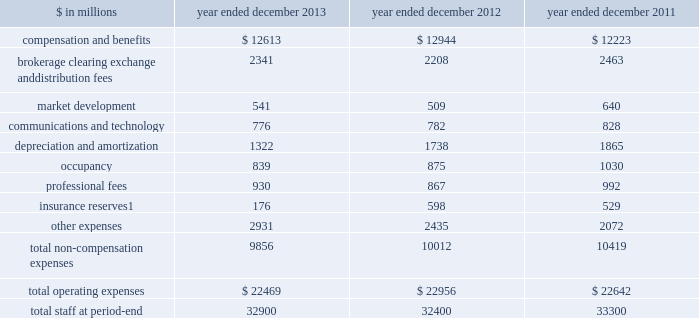Management 2019s discussion and analysis net interest income 2013 versus 2012 .
Net interest income on the consolidated statements of earnings was $ 3.39 billion for 2013 , 13% ( 13 % ) lower than 2012 .
The decrease compared with 2012 was primarily due to lower average yields on financial instruments owned , at fair value , partially offset by lower interest expense on financial instruments sold , but not yet purchased , at fair value and collateralized financings .
2012 versus 2011 .
Net interest income on the consolidated statements of earnings was $ 3.88 billion for 2012 , 25% ( 25 % ) lower than 2011 .
The decrease compared with 2011 was primarily due to lower average yields on financial instruments owned , at fair value and collateralized agreements .
See 201cstatistical disclosures 2014 distribution of assets , liabilities and shareholders 2019 equity 201d for further information about our sources of net interest income .
Operating expenses our operating expenses are primarily influenced by compensation , headcount and levels of business activity .
Compensation and benefits includes salaries , discretionary compensation , amortization of equity awards and other items such as benefits .
Discretionary compensation is significantly impacted by , among other factors , the level of net revenues , overall financial performance , prevailing labor markets , business mix , the structure of our share-based compensation programs and the external environment .
The table below presents our operating expenses and total staff ( which includes employees , consultants and temporary staff ) . .
Related revenues are included in 201cmarket making 201d in the consolidated statements of earnings .
Goldman sachs 2013 annual report 45 .
What is the net interest income in 2011? 
Computations: (3.88 / (100 - 25))
Answer: 0.05173. 